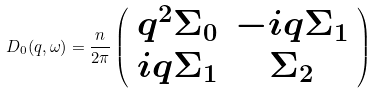Convert formula to latex. <formula><loc_0><loc_0><loc_500><loc_500>D _ { 0 } ( { q } , \omega ) = \frac { n } { 2 \pi } \left ( \begin{array} { c c } q ^ { 2 } \Sigma _ { 0 } & - i q \Sigma _ { 1 } \\ i q \Sigma _ { 1 } & \Sigma _ { 2 } \end{array} \right )</formula> 